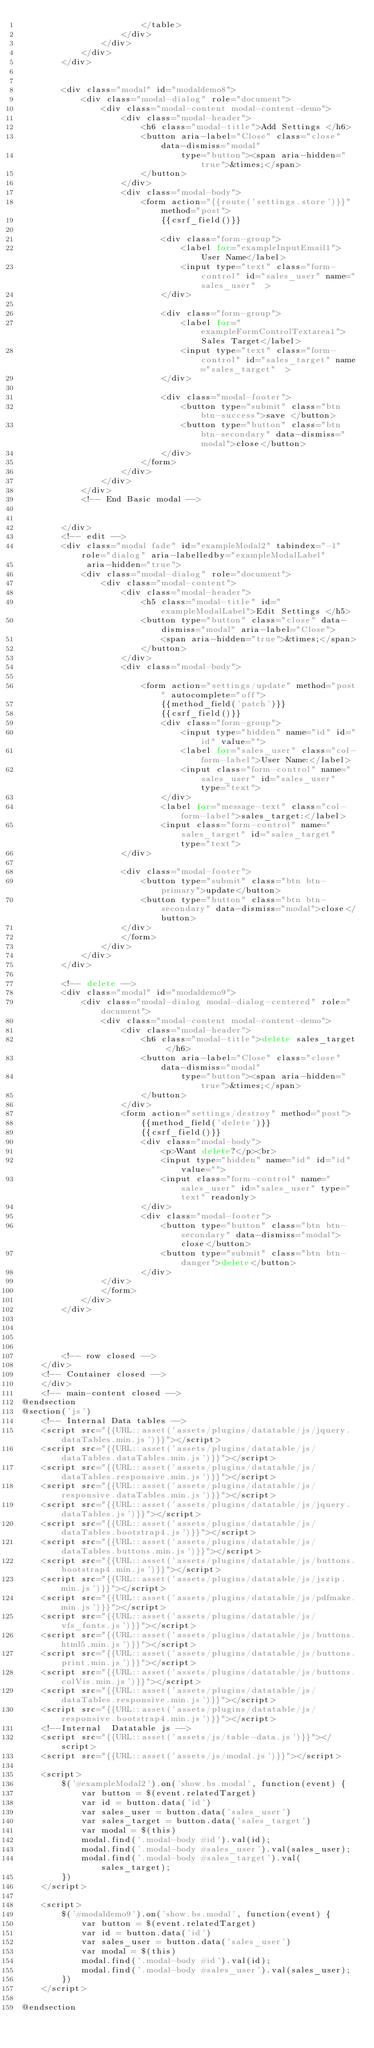Convert code to text. <code><loc_0><loc_0><loc_500><loc_500><_PHP_>                        </table>
                    </div>
                </div>
            </div>
        </div>


        <div class="modal" id="modaldemo8">
            <div class="modal-dialog" role="document">
                <div class="modal-content modal-content-demo">
                    <div class="modal-header">
                        <h6 class="modal-title">Add Settings </h6>
                        <button aria-label="Close" class="close" data-dismiss="modal"
                                type="button"><span aria-hidden="true">&times;</span>
                        </button>
                    </div>
                    <div class="modal-body">
                        <form action="{{route('settings.store')}}" method="post">
                            {{csrf_field()}}

                            <div class="form-group">
                                <label for="exampleInputEmail1">User Name</label>
                                <input type="text" class="form-control" id="sales_user" name="sales_user"  >
                            </div>

                            <div class="form-group">
                                <label for="exampleFormControlTextarea1">Sales Target</label>
                                <input type="text" class="form-control" id="sales_target" name="sales_target"  >
                            </div>

                            <div class="modal-footer">
                                <button type="submit" class="btn btn-success">save </button>
                                <button type="button" class="btn btn-secondary" data-dismiss="modal">close</button>
                            </div>
                        </form>
                    </div>
                </div>
            </div>
            <!-- End Basic modal -->


        </div>
        <!-- edit -->
        <div class="modal fade" id="exampleModal2" tabindex="-1" role="dialog" aria-labelledby="exampleModalLabel"
             aria-hidden="true">
            <div class="modal-dialog" role="document">
                <div class="modal-content">
                    <div class="modal-header">
                        <h5 class="modal-title" id="exampleModalLabel">Edit Settings </h5>
                        <button type="button" class="close" data-dismiss="modal" aria-label="Close">
                            <span aria-hidden="true">&times;</span>
                        </button>
                    </div>
                    <div class="modal-body">

                        <form action="settings/update" method="post" autocomplete="off">
                            {{method_field('patch')}}
                            {{csrf_field()}}
                            <div class="form-group">
                                <input type="hidden" name="id" id="id" value="">
                                <label for="sales_user" class="col-form-label">User Name:</label>
                                <input class="form-control" name="sales_user" id="sales_user" type="text">
                            </div>
                            <label for="message-text" class="col-form-label">sales_target:</label>
                            <input class="form-control" name="sales_target" id="sales_target" type="text">
                    </div>

                    <div class="modal-footer">
                        <button type="submit" class="btn btn-primary">update</button>
                        <button type="button" class="btn btn-secondary" data-dismiss="modal">close</button>
                    </div>
                    </form>
                </div>
            </div>
        </div>

        <!-- delete -->
        <div class="modal" id="modaldemo9">
            <div class="modal-dialog modal-dialog-centered" role="document">
                <div class="modal-content modal-content-demo">
                    <div class="modal-header">
                        <h6 class="modal-title">delete sales_target </h6>
                        <button aria-label="Close" class="close" data-dismiss="modal"
                                type="button"><span aria-hidden="true">&times;</span>
                        </button>
                    </div>
                    <form action="settings/destroy" method="post">
                        {{method_field('delete')}}
                        {{csrf_field()}}
                        <div class="modal-body">
                            <p>Want delete?</p><br>
                            <input type="hidden" name="id" id="id" value="">
                            <input class="form-control" name="sales_user" id="sales_user" type="text" readonly>
                        </div>
                        <div class="modal-footer">
                            <button type="button" class="btn btn-secondary" data-dismiss="modal">close</button>
                            <button type="submit" class="btn btn-danger">delete</button>
                        </div>
                </div>
                </form>
            </div>
        </div>




        <!-- row closed -->
    </div>
    <!-- Container closed -->
    </div>
    <!-- main-content closed -->
@endsection
@section('js')
    <!-- Internal Data tables -->
    <script src="{{URL::asset('assets/plugins/datatable/js/jquery.dataTables.min.js')}}"></script>
    <script src="{{URL::asset('assets/plugins/datatable/js/dataTables.dataTables.min.js')}}"></script>
    <script src="{{URL::asset('assets/plugins/datatable/js/dataTables.responsive.min.js')}}"></script>
    <script src="{{URL::asset('assets/plugins/datatable/js/responsive.dataTables.min.js')}}"></script>
    <script src="{{URL::asset('assets/plugins/datatable/js/jquery.dataTables.js')}}"></script>
    <script src="{{URL::asset('assets/plugins/datatable/js/dataTables.bootstrap4.js')}}"></script>
    <script src="{{URL::asset('assets/plugins/datatable/js/dataTables.buttons.min.js')}}"></script>
    <script src="{{URL::asset('assets/plugins/datatable/js/buttons.bootstrap4.min.js')}}"></script>
    <script src="{{URL::asset('assets/plugins/datatable/js/jszip.min.js')}}"></script>
    <script src="{{URL::asset('assets/plugins/datatable/js/pdfmake.min.js')}}"></script>
    <script src="{{URL::asset('assets/plugins/datatable/js/vfs_fonts.js')}}"></script>
    <script src="{{URL::asset('assets/plugins/datatable/js/buttons.html5.min.js')}}"></script>
    <script src="{{URL::asset('assets/plugins/datatable/js/buttons.print.min.js')}}"></script>
    <script src="{{URL::asset('assets/plugins/datatable/js/buttons.colVis.min.js')}}"></script>
    <script src="{{URL::asset('assets/plugins/datatable/js/dataTables.responsive.min.js')}}"></script>
    <script src="{{URL::asset('assets/plugins/datatable/js/responsive.bootstrap4.min.js')}}"></script>
    <!--Internal  Datatable js -->
    <script src="{{URL::asset('assets/js/table-data.js')}}"></script>
    <script src="{{URL::asset('assets/js/modal.js')}}"></script>

    <script>
        $('#exampleModal2').on('show.bs.modal', function(event) {
            var button = $(event.relatedTarget)
            var id = button.data('id')
            var sales_user = button.data('sales_user')
            var sales_target = button.data('sales_target')
            var modal = $(this)
            modal.find('.modal-body #id').val(id);
            modal.find('.modal-body #sales_user').val(sales_user);
            modal.find('.modal-body #sales_target').val(sales_target);
        })
    </script>

    <script>
        $('#modaldemo9').on('show.bs.modal', function(event) {
            var button = $(event.relatedTarget)
            var id = button.data('id')
            var sales_user = button.data('sales_user')
            var modal = $(this)
            modal.find('.modal-body #id').val(id);
            modal.find('.modal-body #sales_user').val(sales_user);
        })
    </script>

@endsection
</code> 